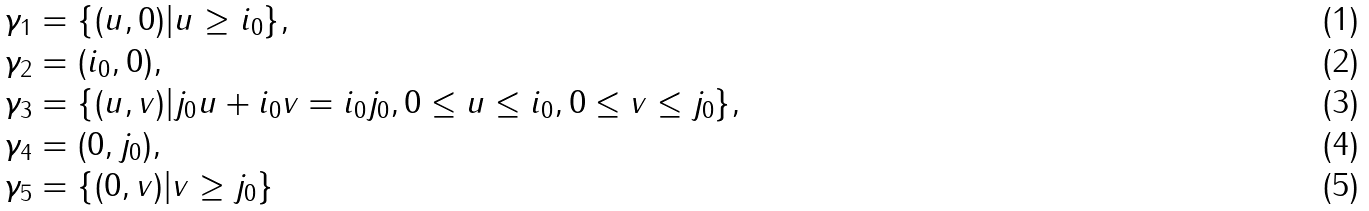Convert formula to latex. <formula><loc_0><loc_0><loc_500><loc_500>\gamma _ { 1 } & = \{ ( u , 0 ) | u \geq i _ { 0 } \} , \\ \gamma _ { 2 } & = ( i _ { 0 } , 0 ) , \\ \gamma _ { 3 } & = \{ ( u , v ) | j _ { 0 } u + i _ { 0 } v = i _ { 0 } j _ { 0 } , 0 \leq u \leq i _ { 0 } , 0 \leq v \leq j _ { 0 } \} , \\ \gamma _ { 4 } & = ( 0 , j _ { 0 } ) , \\ \gamma _ { 5 } & = \{ ( 0 , v ) | v \geq j _ { 0 } \}</formula> 